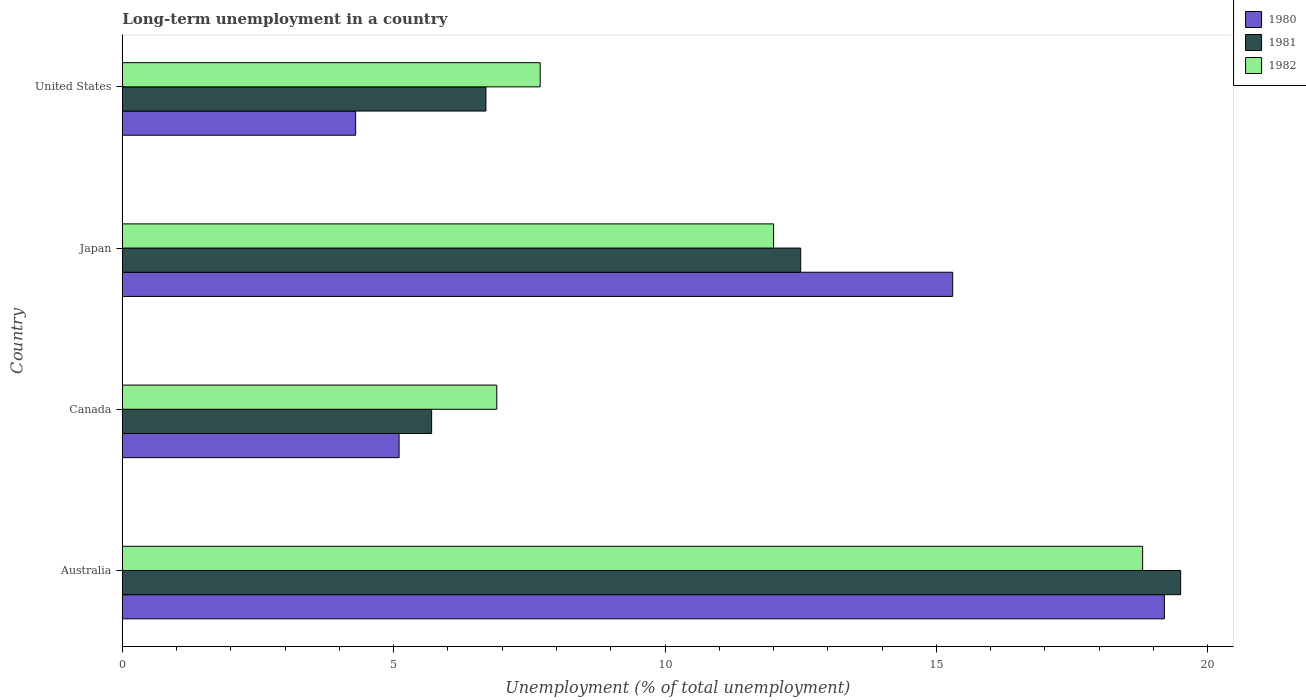How many different coloured bars are there?
Keep it short and to the point. 3. Are the number of bars on each tick of the Y-axis equal?
Provide a succinct answer. Yes. How many bars are there on the 2nd tick from the top?
Your answer should be compact. 3. What is the label of the 2nd group of bars from the top?
Provide a short and direct response. Japan. In how many cases, is the number of bars for a given country not equal to the number of legend labels?
Offer a very short reply. 0. What is the percentage of long-term unemployed population in 1982 in United States?
Provide a short and direct response. 7.7. Across all countries, what is the maximum percentage of long-term unemployed population in 1980?
Provide a succinct answer. 19.2. Across all countries, what is the minimum percentage of long-term unemployed population in 1981?
Keep it short and to the point. 5.7. In which country was the percentage of long-term unemployed population in 1980 minimum?
Keep it short and to the point. United States. What is the total percentage of long-term unemployed population in 1980 in the graph?
Give a very brief answer. 43.9. What is the difference between the percentage of long-term unemployed population in 1981 in Australia and that in Japan?
Offer a very short reply. 7. What is the average percentage of long-term unemployed population in 1982 per country?
Offer a terse response. 11.35. What is the difference between the percentage of long-term unemployed population in 1982 and percentage of long-term unemployed population in 1981 in Canada?
Give a very brief answer. 1.2. What is the ratio of the percentage of long-term unemployed population in 1980 in Canada to that in Japan?
Offer a very short reply. 0.33. Is the percentage of long-term unemployed population in 1981 in Canada less than that in Japan?
Offer a terse response. Yes. What is the difference between the highest and the second highest percentage of long-term unemployed population in 1982?
Make the answer very short. 6.8. What is the difference between the highest and the lowest percentage of long-term unemployed population in 1982?
Your answer should be compact. 11.9. In how many countries, is the percentage of long-term unemployed population in 1982 greater than the average percentage of long-term unemployed population in 1982 taken over all countries?
Your response must be concise. 2. Is the sum of the percentage of long-term unemployed population in 1981 in Canada and Japan greater than the maximum percentage of long-term unemployed population in 1980 across all countries?
Give a very brief answer. No. What does the 1st bar from the bottom in United States represents?
Provide a short and direct response. 1980. How many bars are there?
Make the answer very short. 12. Are the values on the major ticks of X-axis written in scientific E-notation?
Offer a very short reply. No. Where does the legend appear in the graph?
Provide a short and direct response. Top right. How many legend labels are there?
Your answer should be compact. 3. How are the legend labels stacked?
Offer a very short reply. Vertical. What is the title of the graph?
Your response must be concise. Long-term unemployment in a country. What is the label or title of the X-axis?
Give a very brief answer. Unemployment (% of total unemployment). What is the Unemployment (% of total unemployment) in 1980 in Australia?
Keep it short and to the point. 19.2. What is the Unemployment (% of total unemployment) in 1981 in Australia?
Your answer should be very brief. 19.5. What is the Unemployment (% of total unemployment) of 1982 in Australia?
Your response must be concise. 18.8. What is the Unemployment (% of total unemployment) of 1980 in Canada?
Give a very brief answer. 5.1. What is the Unemployment (% of total unemployment) of 1981 in Canada?
Offer a terse response. 5.7. What is the Unemployment (% of total unemployment) of 1982 in Canada?
Keep it short and to the point. 6.9. What is the Unemployment (% of total unemployment) in 1980 in Japan?
Offer a terse response. 15.3. What is the Unemployment (% of total unemployment) in 1982 in Japan?
Offer a very short reply. 12. What is the Unemployment (% of total unemployment) in 1980 in United States?
Provide a succinct answer. 4.3. What is the Unemployment (% of total unemployment) in 1981 in United States?
Ensure brevity in your answer.  6.7. What is the Unemployment (% of total unemployment) of 1982 in United States?
Make the answer very short. 7.7. Across all countries, what is the maximum Unemployment (% of total unemployment) of 1980?
Provide a short and direct response. 19.2. Across all countries, what is the maximum Unemployment (% of total unemployment) of 1981?
Your answer should be very brief. 19.5. Across all countries, what is the maximum Unemployment (% of total unemployment) of 1982?
Offer a terse response. 18.8. Across all countries, what is the minimum Unemployment (% of total unemployment) of 1980?
Provide a short and direct response. 4.3. Across all countries, what is the minimum Unemployment (% of total unemployment) in 1981?
Offer a terse response. 5.7. Across all countries, what is the minimum Unemployment (% of total unemployment) of 1982?
Give a very brief answer. 6.9. What is the total Unemployment (% of total unemployment) in 1980 in the graph?
Your answer should be compact. 43.9. What is the total Unemployment (% of total unemployment) of 1981 in the graph?
Offer a terse response. 44.4. What is the total Unemployment (% of total unemployment) of 1982 in the graph?
Keep it short and to the point. 45.4. What is the difference between the Unemployment (% of total unemployment) of 1981 in Australia and that in Canada?
Your response must be concise. 13.8. What is the difference between the Unemployment (% of total unemployment) in 1982 in Australia and that in Canada?
Offer a very short reply. 11.9. What is the difference between the Unemployment (% of total unemployment) of 1980 in Australia and that in Japan?
Your answer should be compact. 3.9. What is the difference between the Unemployment (% of total unemployment) of 1981 in Australia and that in Japan?
Ensure brevity in your answer.  7. What is the difference between the Unemployment (% of total unemployment) in 1980 in Australia and that in United States?
Your answer should be very brief. 14.9. What is the difference between the Unemployment (% of total unemployment) in 1980 in Canada and that in United States?
Offer a terse response. 0.8. What is the difference between the Unemployment (% of total unemployment) of 1982 in Canada and that in United States?
Make the answer very short. -0.8. What is the difference between the Unemployment (% of total unemployment) in 1980 in Japan and that in United States?
Keep it short and to the point. 11. What is the difference between the Unemployment (% of total unemployment) of 1981 in Japan and that in United States?
Provide a succinct answer. 5.8. What is the difference between the Unemployment (% of total unemployment) of 1982 in Japan and that in United States?
Give a very brief answer. 4.3. What is the difference between the Unemployment (% of total unemployment) in 1980 in Australia and the Unemployment (% of total unemployment) in 1981 in Canada?
Your answer should be very brief. 13.5. What is the difference between the Unemployment (% of total unemployment) of 1980 in Australia and the Unemployment (% of total unemployment) of 1982 in Japan?
Your answer should be compact. 7.2. What is the difference between the Unemployment (% of total unemployment) of 1981 in Australia and the Unemployment (% of total unemployment) of 1982 in Japan?
Keep it short and to the point. 7.5. What is the difference between the Unemployment (% of total unemployment) in 1980 in Canada and the Unemployment (% of total unemployment) in 1981 in United States?
Ensure brevity in your answer.  -1.6. What is the difference between the Unemployment (% of total unemployment) in 1980 in Japan and the Unemployment (% of total unemployment) in 1982 in United States?
Provide a short and direct response. 7.6. What is the average Unemployment (% of total unemployment) in 1980 per country?
Offer a terse response. 10.97. What is the average Unemployment (% of total unemployment) of 1981 per country?
Ensure brevity in your answer.  11.1. What is the average Unemployment (% of total unemployment) in 1982 per country?
Your response must be concise. 11.35. What is the difference between the Unemployment (% of total unemployment) in 1980 and Unemployment (% of total unemployment) in 1981 in Canada?
Ensure brevity in your answer.  -0.6. What is the difference between the Unemployment (% of total unemployment) in 1981 and Unemployment (% of total unemployment) in 1982 in Canada?
Your answer should be very brief. -1.2. What is the difference between the Unemployment (% of total unemployment) in 1980 and Unemployment (% of total unemployment) in 1982 in Japan?
Your answer should be compact. 3.3. What is the difference between the Unemployment (% of total unemployment) in 1981 and Unemployment (% of total unemployment) in 1982 in Japan?
Your answer should be very brief. 0.5. What is the difference between the Unemployment (% of total unemployment) of 1980 and Unemployment (% of total unemployment) of 1981 in United States?
Your answer should be very brief. -2.4. What is the ratio of the Unemployment (% of total unemployment) in 1980 in Australia to that in Canada?
Provide a succinct answer. 3.76. What is the ratio of the Unemployment (% of total unemployment) in 1981 in Australia to that in Canada?
Your answer should be compact. 3.42. What is the ratio of the Unemployment (% of total unemployment) of 1982 in Australia to that in Canada?
Provide a succinct answer. 2.72. What is the ratio of the Unemployment (% of total unemployment) in 1980 in Australia to that in Japan?
Provide a short and direct response. 1.25. What is the ratio of the Unemployment (% of total unemployment) of 1981 in Australia to that in Japan?
Ensure brevity in your answer.  1.56. What is the ratio of the Unemployment (% of total unemployment) of 1982 in Australia to that in Japan?
Offer a very short reply. 1.57. What is the ratio of the Unemployment (% of total unemployment) of 1980 in Australia to that in United States?
Offer a very short reply. 4.47. What is the ratio of the Unemployment (% of total unemployment) in 1981 in Australia to that in United States?
Offer a terse response. 2.91. What is the ratio of the Unemployment (% of total unemployment) in 1982 in Australia to that in United States?
Make the answer very short. 2.44. What is the ratio of the Unemployment (% of total unemployment) of 1981 in Canada to that in Japan?
Provide a short and direct response. 0.46. What is the ratio of the Unemployment (% of total unemployment) of 1982 in Canada to that in Japan?
Offer a terse response. 0.57. What is the ratio of the Unemployment (% of total unemployment) of 1980 in Canada to that in United States?
Offer a very short reply. 1.19. What is the ratio of the Unemployment (% of total unemployment) in 1981 in Canada to that in United States?
Provide a short and direct response. 0.85. What is the ratio of the Unemployment (% of total unemployment) in 1982 in Canada to that in United States?
Your answer should be very brief. 0.9. What is the ratio of the Unemployment (% of total unemployment) of 1980 in Japan to that in United States?
Ensure brevity in your answer.  3.56. What is the ratio of the Unemployment (% of total unemployment) of 1981 in Japan to that in United States?
Your response must be concise. 1.87. What is the ratio of the Unemployment (% of total unemployment) of 1982 in Japan to that in United States?
Provide a short and direct response. 1.56. What is the difference between the highest and the second highest Unemployment (% of total unemployment) in 1980?
Provide a short and direct response. 3.9. What is the difference between the highest and the second highest Unemployment (% of total unemployment) in 1982?
Keep it short and to the point. 6.8. What is the difference between the highest and the lowest Unemployment (% of total unemployment) of 1981?
Offer a terse response. 13.8. 